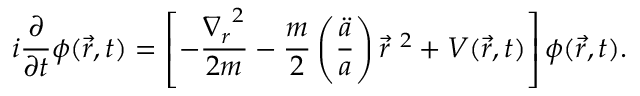<formula> <loc_0><loc_0><loc_500><loc_500>i \frac { \partial } { \partial t } \phi ( \vec { r } , t ) = \left [ - \frac { { \nabla _ { r } } ^ { 2 } } { 2 m } - \frac { m } { 2 } \left ( \frac { \ddot { a } } { a } \right ) { \vec { r } } ^ { \ 2 } + V ( \vec { r } , t ) \right ] \phi ( \vec { r } , t ) .</formula> 